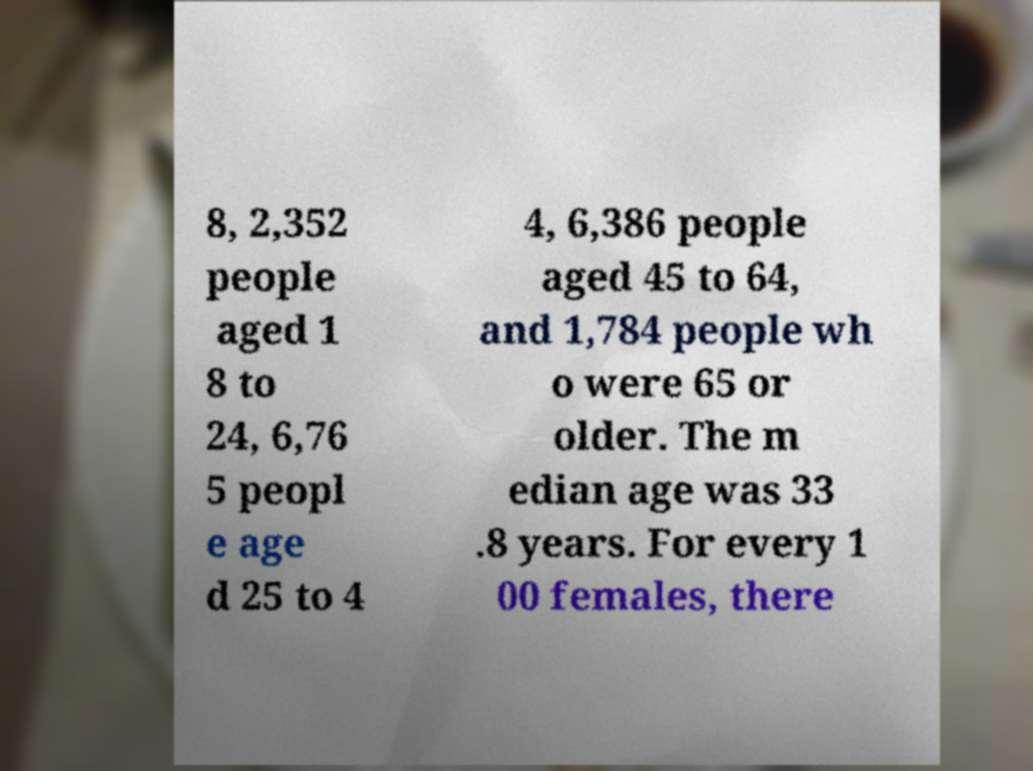Can you read and provide the text displayed in the image?This photo seems to have some interesting text. Can you extract and type it out for me? 8, 2,352 people aged 1 8 to 24, 6,76 5 peopl e age d 25 to 4 4, 6,386 people aged 45 to 64, and 1,784 people wh o were 65 or older. The m edian age was 33 .8 years. For every 1 00 females, there 